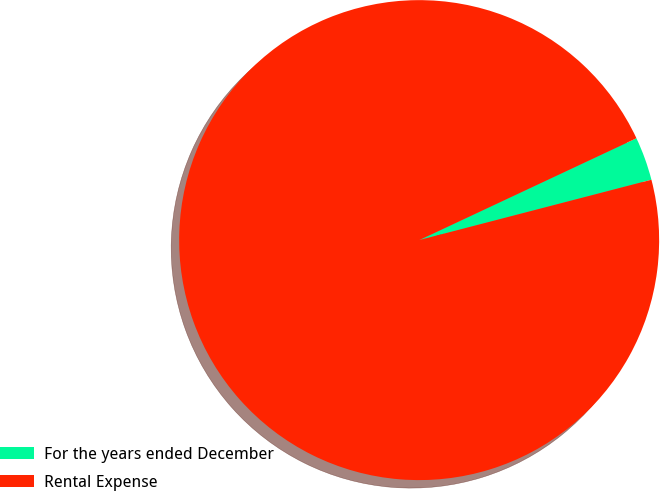<chart> <loc_0><loc_0><loc_500><loc_500><pie_chart><fcel>For the years ended December<fcel>Rental Expense<nl><fcel>2.93%<fcel>97.07%<nl></chart> 